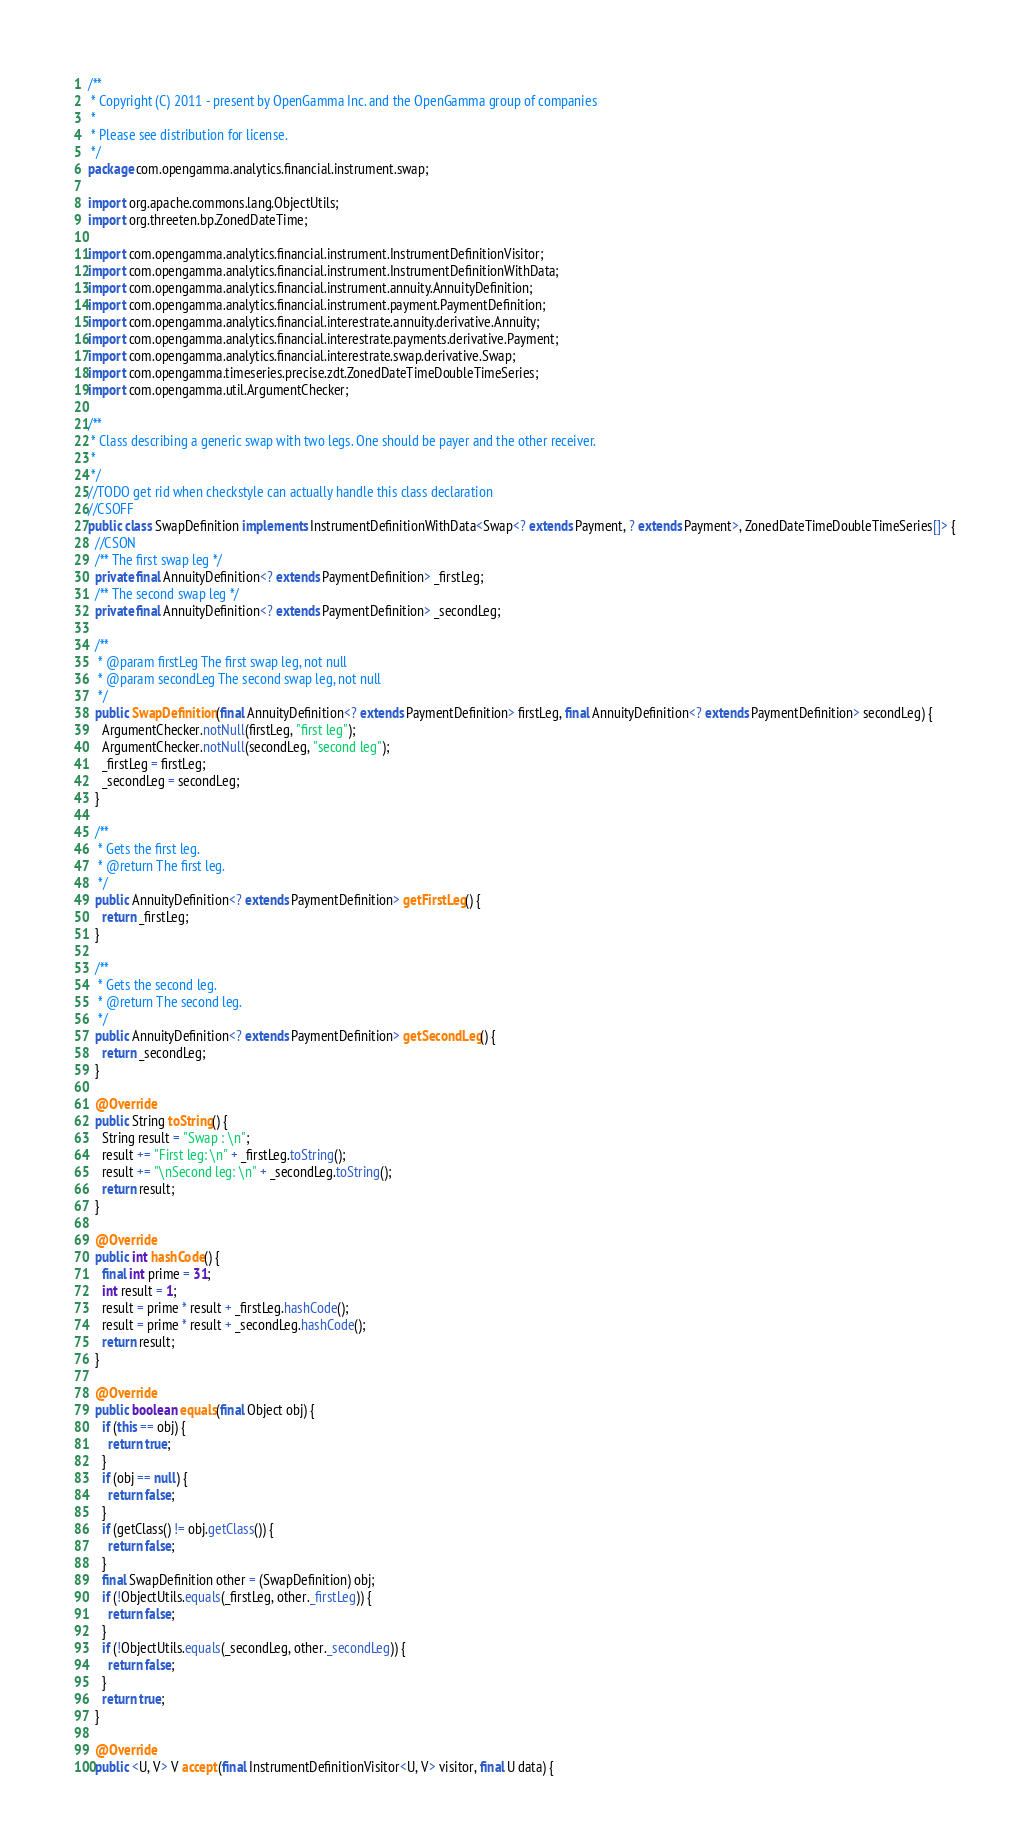Convert code to text. <code><loc_0><loc_0><loc_500><loc_500><_Java_>/**
 * Copyright (C) 2011 - present by OpenGamma Inc. and the OpenGamma group of companies
 *
 * Please see distribution for license.
 */
package com.opengamma.analytics.financial.instrument.swap;

import org.apache.commons.lang.ObjectUtils;
import org.threeten.bp.ZonedDateTime;

import com.opengamma.analytics.financial.instrument.InstrumentDefinitionVisitor;
import com.opengamma.analytics.financial.instrument.InstrumentDefinitionWithData;
import com.opengamma.analytics.financial.instrument.annuity.AnnuityDefinition;
import com.opengamma.analytics.financial.instrument.payment.PaymentDefinition;
import com.opengamma.analytics.financial.interestrate.annuity.derivative.Annuity;
import com.opengamma.analytics.financial.interestrate.payments.derivative.Payment;
import com.opengamma.analytics.financial.interestrate.swap.derivative.Swap;
import com.opengamma.timeseries.precise.zdt.ZonedDateTimeDoubleTimeSeries;
import com.opengamma.util.ArgumentChecker;

/**
 * Class describing a generic swap with two legs. One should be payer and the other receiver.
 *
 */
//TODO get rid when checkstyle can actually handle this class declaration
//CSOFF
public class SwapDefinition implements InstrumentDefinitionWithData<Swap<? extends Payment, ? extends Payment>, ZonedDateTimeDoubleTimeSeries[]> {
  //CSON
  /** The first swap leg */
  private final AnnuityDefinition<? extends PaymentDefinition> _firstLeg;
  /** The second swap leg */
  private final AnnuityDefinition<? extends PaymentDefinition> _secondLeg;

  /**
   * @param firstLeg The first swap leg, not null
   * @param secondLeg The second swap leg, not null
   */
  public SwapDefinition(final AnnuityDefinition<? extends PaymentDefinition> firstLeg, final AnnuityDefinition<? extends PaymentDefinition> secondLeg) {
    ArgumentChecker.notNull(firstLeg, "first leg");
    ArgumentChecker.notNull(secondLeg, "second leg");
    _firstLeg = firstLeg;
    _secondLeg = secondLeg;
  }

  /**
   * Gets the first leg.
   * @return The first leg.
   */
  public AnnuityDefinition<? extends PaymentDefinition> getFirstLeg() {
    return _firstLeg;
  }

  /**
   * Gets the second leg.
   * @return The second leg.
   */
  public AnnuityDefinition<? extends PaymentDefinition> getSecondLeg() {
    return _secondLeg;
  }

  @Override
  public String toString() {
    String result = "Swap : \n";
    result += "First leg: \n" + _firstLeg.toString();
    result += "\nSecond leg: \n" + _secondLeg.toString();
    return result;
  }

  @Override
  public int hashCode() {
    final int prime = 31;
    int result = 1;
    result = prime * result + _firstLeg.hashCode();
    result = prime * result + _secondLeg.hashCode();
    return result;
  }

  @Override
  public boolean equals(final Object obj) {
    if (this == obj) {
      return true;
    }
    if (obj == null) {
      return false;
    }
    if (getClass() != obj.getClass()) {
      return false;
    }
    final SwapDefinition other = (SwapDefinition) obj;
    if (!ObjectUtils.equals(_firstLeg, other._firstLeg)) {
      return false;
    }
    if (!ObjectUtils.equals(_secondLeg, other._secondLeg)) {
      return false;
    }
    return true;
  }

  @Override
  public <U, V> V accept(final InstrumentDefinitionVisitor<U, V> visitor, final U data) {</code> 